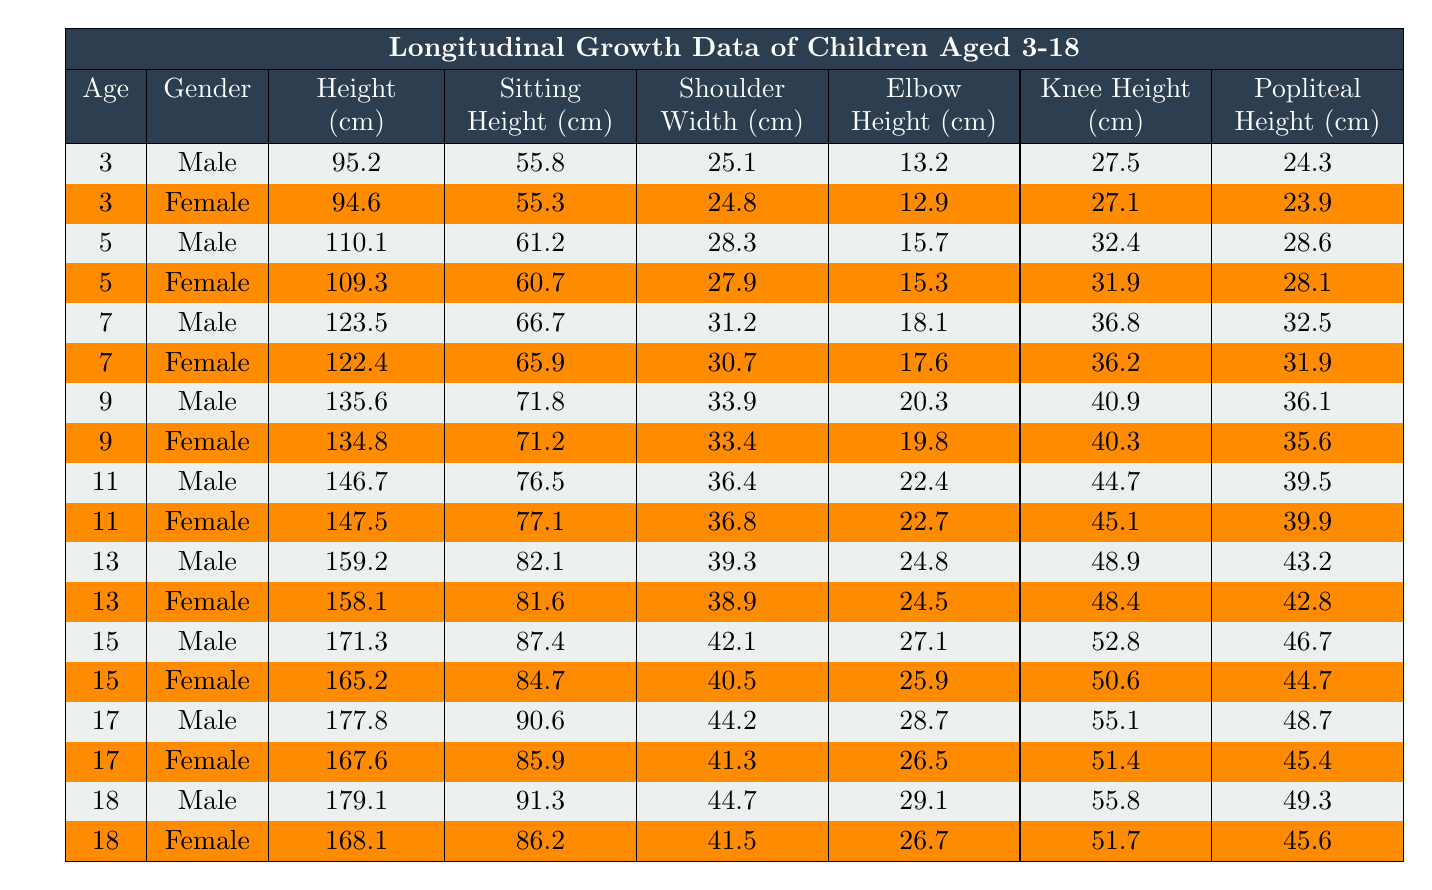What is the height of a 9-year-old male? Looking at the table, I find the row for a 9-year-old male. The height listed is 135.6 cm.
Answer: 135.6 cm What is the sitting height for a 5-year-old female? I locate the row for a 5-year-old female in the table, where the sitting height is 60.7 cm.
Answer: 60.7 cm How does the shoulder width of a 15-year-old male compare to that of a 15-year-old female? I find the shoulder width for both 15-year-old male (42.1 cm) and female (40.5 cm) in the table, and note that the male's shoulder width is larger by 1.6 cm.
Answer: 1.6 cm What is the average knee height for all males aged 3-18? To find the average knee height for males, I sum up all the knee heights of males and divide by the number of males (8 males): (24.3 + 28.6 + 32.5 + 36.1 + 39.5 + 43.2 + 46.7 + 49.3) = 359.2 cm, and 359.2/8 = 44.9 cm.
Answer: 44.9 cm Is the popliteal height of a 7-year-old female greater than that of an 11-year-old male? I check both entries: the popliteal height of the 7-year-old female is 31.9 cm while the 11-year-old male's is 39.5 cm; since 31.9 cm < 39.5 cm, the statement is false.
Answer: No What is the difference in height between the tallest 18-year-old male and the shortest 3-year-old female? The 18-year-old male is 179.1 cm tall, and the 3-year-old female is 94.6 cm tall. The difference is 179.1 - 94.6 = 84.5 cm.
Answer: 84.5 cm How many data points are there for females aged 15 or older? I review the table and find there are three entries for females aged 15: one for 15, one for 17, and another for 18, totaling three data points.
Answer: 3 Which gender has a greater average sitting height at age 13? I find the sitting heights for both genders at age 13: male is 82.1 cm and female is 81.6 cm. The average sitting height is greater for males by 0.5 cm.
Answer: Males have a greater average What is the maximum height recorded for any child in the table? By scanning the height entries, the tallest recorded height is 179.1 cm from the 18-year-old male.
Answer: 179.1 cm Are the knee heights of all males in this dataset greater than 30 cm? I check every knee height value for males: 24.3, 28.6, 32.5, 36.1, 39.5, 43.2, 46.7, and 49.3 cm, finding that 24.3 and 28.6 cm are below 30 cm; thus, the statement is false.
Answer: No What is the total of sitting heights for all the females aged 3-11? I add the sitting heights of females aged 3 (55.3 cm), 5 (60.7 cm), 7 (65.9 cm), and 11 (77.1 cm). Their total is 55.3 + 60.7 + 65.9 + 77.1 = 259 cm.
Answer: 259 cm 